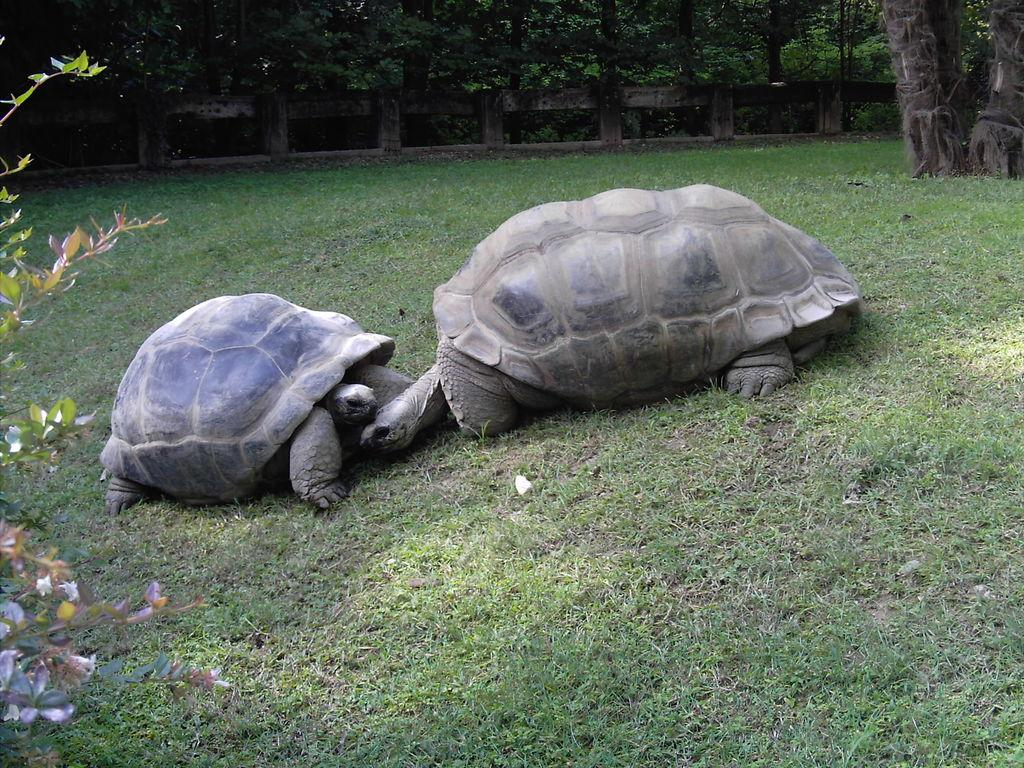What animals can be seen on the ground in the image? There are two tortoises on the ground in the image. What is located on the left side of the image? There is a plant on the left side of the image. What can be seen in the background of the image? There are trees and a boundary visible in the background of the image. What type of vegetation is present on the ground? Grass is present on the ground. What type of flame can be seen coming from the tortoises in the image? There is no flame present in the image; it features two tortoises on the ground. What kind of medical advice can be obtained from the tortoises in the image? The tortoises in the image are not doctors and cannot provide medical advice. 